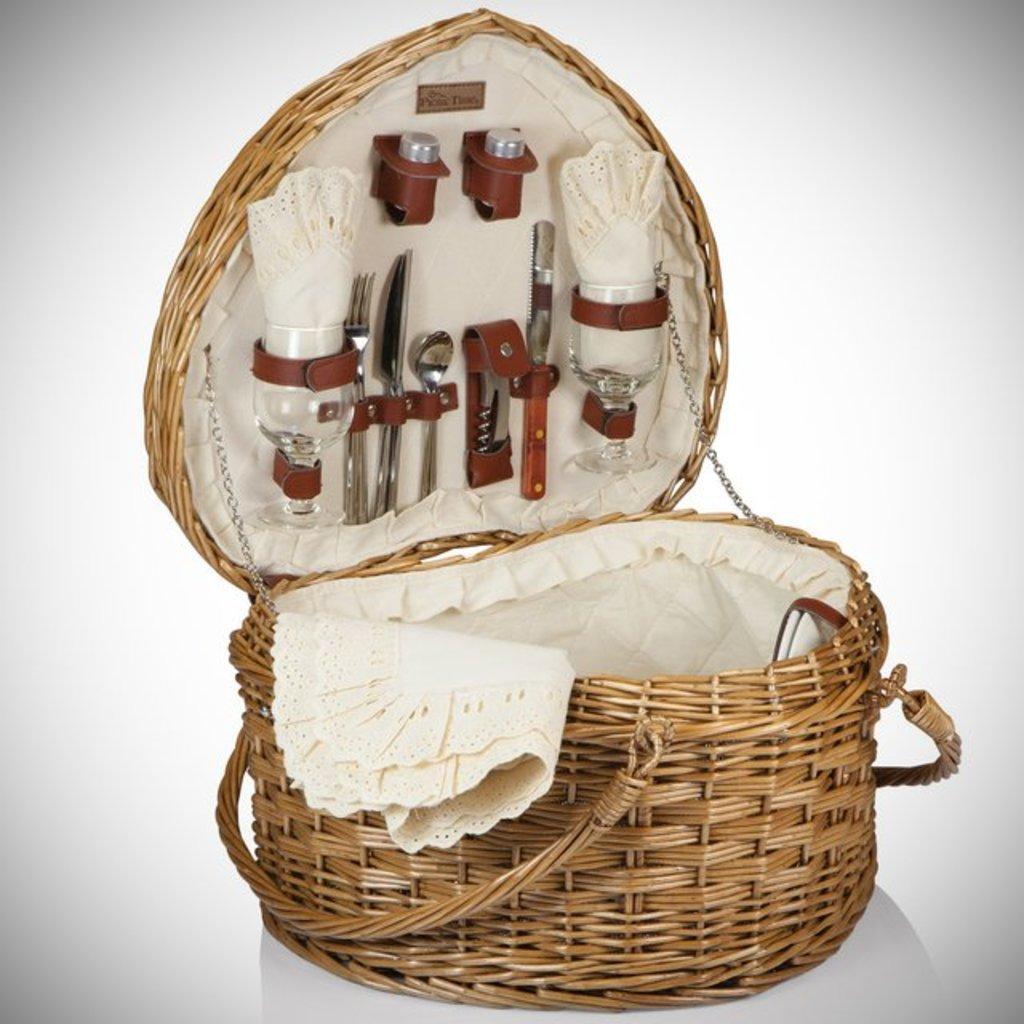In one or two sentences, can you explain what this image depicts? The picture consists of a basket, In the basket there are glasses, spoons, knife, fork and cloth. The picture has white surface and background. 